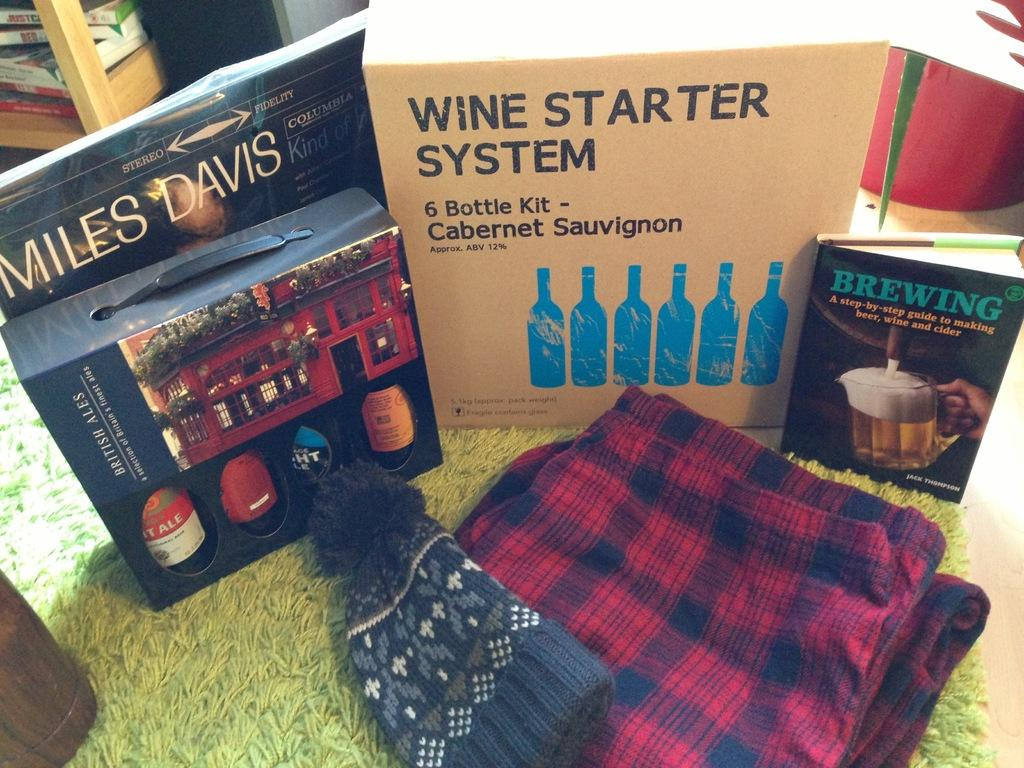<image>
Present a compact description of the photo's key features. Wine Starter System book next to a Brewing book as well. 